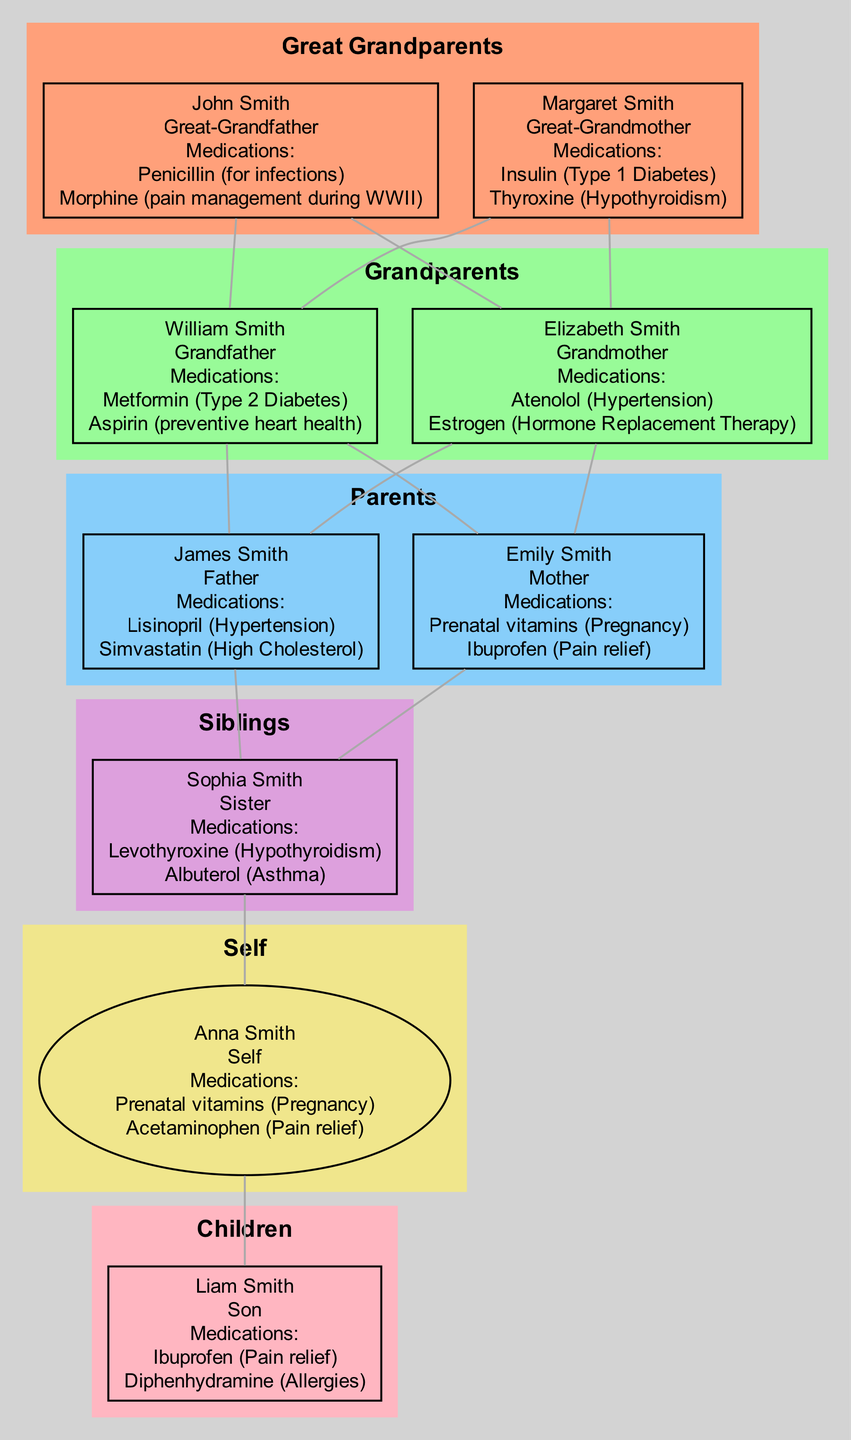What medications did Anna Smith take? In the "self" section of the diagram, Anna Smith is identified, and the medications listed include "Prenatal vitamins (Pregnancy)" and "Acetaminophen (Pain relief)."
Answer: Prenatal vitamins (Pregnancy), Acetaminophen (Pain relief) How many grandparents are represented in the diagram? The grandparents section includes two individuals: William Smith and Elizabeth Smith. Counting these gives a total of 2 grandparents.
Answer: 2 Which great-grandparent used insulin? By analyzing the "great_grandparents" section, it is identified that Margaret Smith used "Insulin (Type 1 Diabetes)."
Answer: Margaret Smith What is Liam's relationship to John Smith? To determine the relationship, trace the connections in the diagram: Liam Smith is the child of Anna Smith, who is the grandchild of William Smith, and William Smith is a child of John Smith, making Liam the great-grandson of John Smith.
Answer: Great-grandson List one medication used for allergies in the family. Liam Smith is noted under the "children" section and uses "Diphenhydramine (Allergies)" for allergies.
Answer: Diphenhydramine How many total medications did the grandparents use? William Smith used 2 medications ("Metformin (Type 2 Diabetes)" and "Aspirin (preventive heart health)"), and Elizabeth Smith also used 2 medications ("Atenolol (Hypertension)" and "Estrogen (Hormone Replacement Therapy)"). Summing these gives a total of 4 medications.
Answer: 4 Which sibling used Albuterol? The siblings section lists Sophia Smith, who is indicated to use "Albuterol (Asthma)."
Answer: Sophia Smith What type of medication did Emily Smith take for pain relief? In the "parents" section, Emily Smith's medications include "Ibuprofen (Pain relief)," which specifies her pain relief medication.
Answer: Ibuprofen How many generations are represented in the family tree? The generations presented in the diagram include great-grandparents, grandparents, parents, siblings, self, and children, making a total of 6 generations.
Answer: 6 